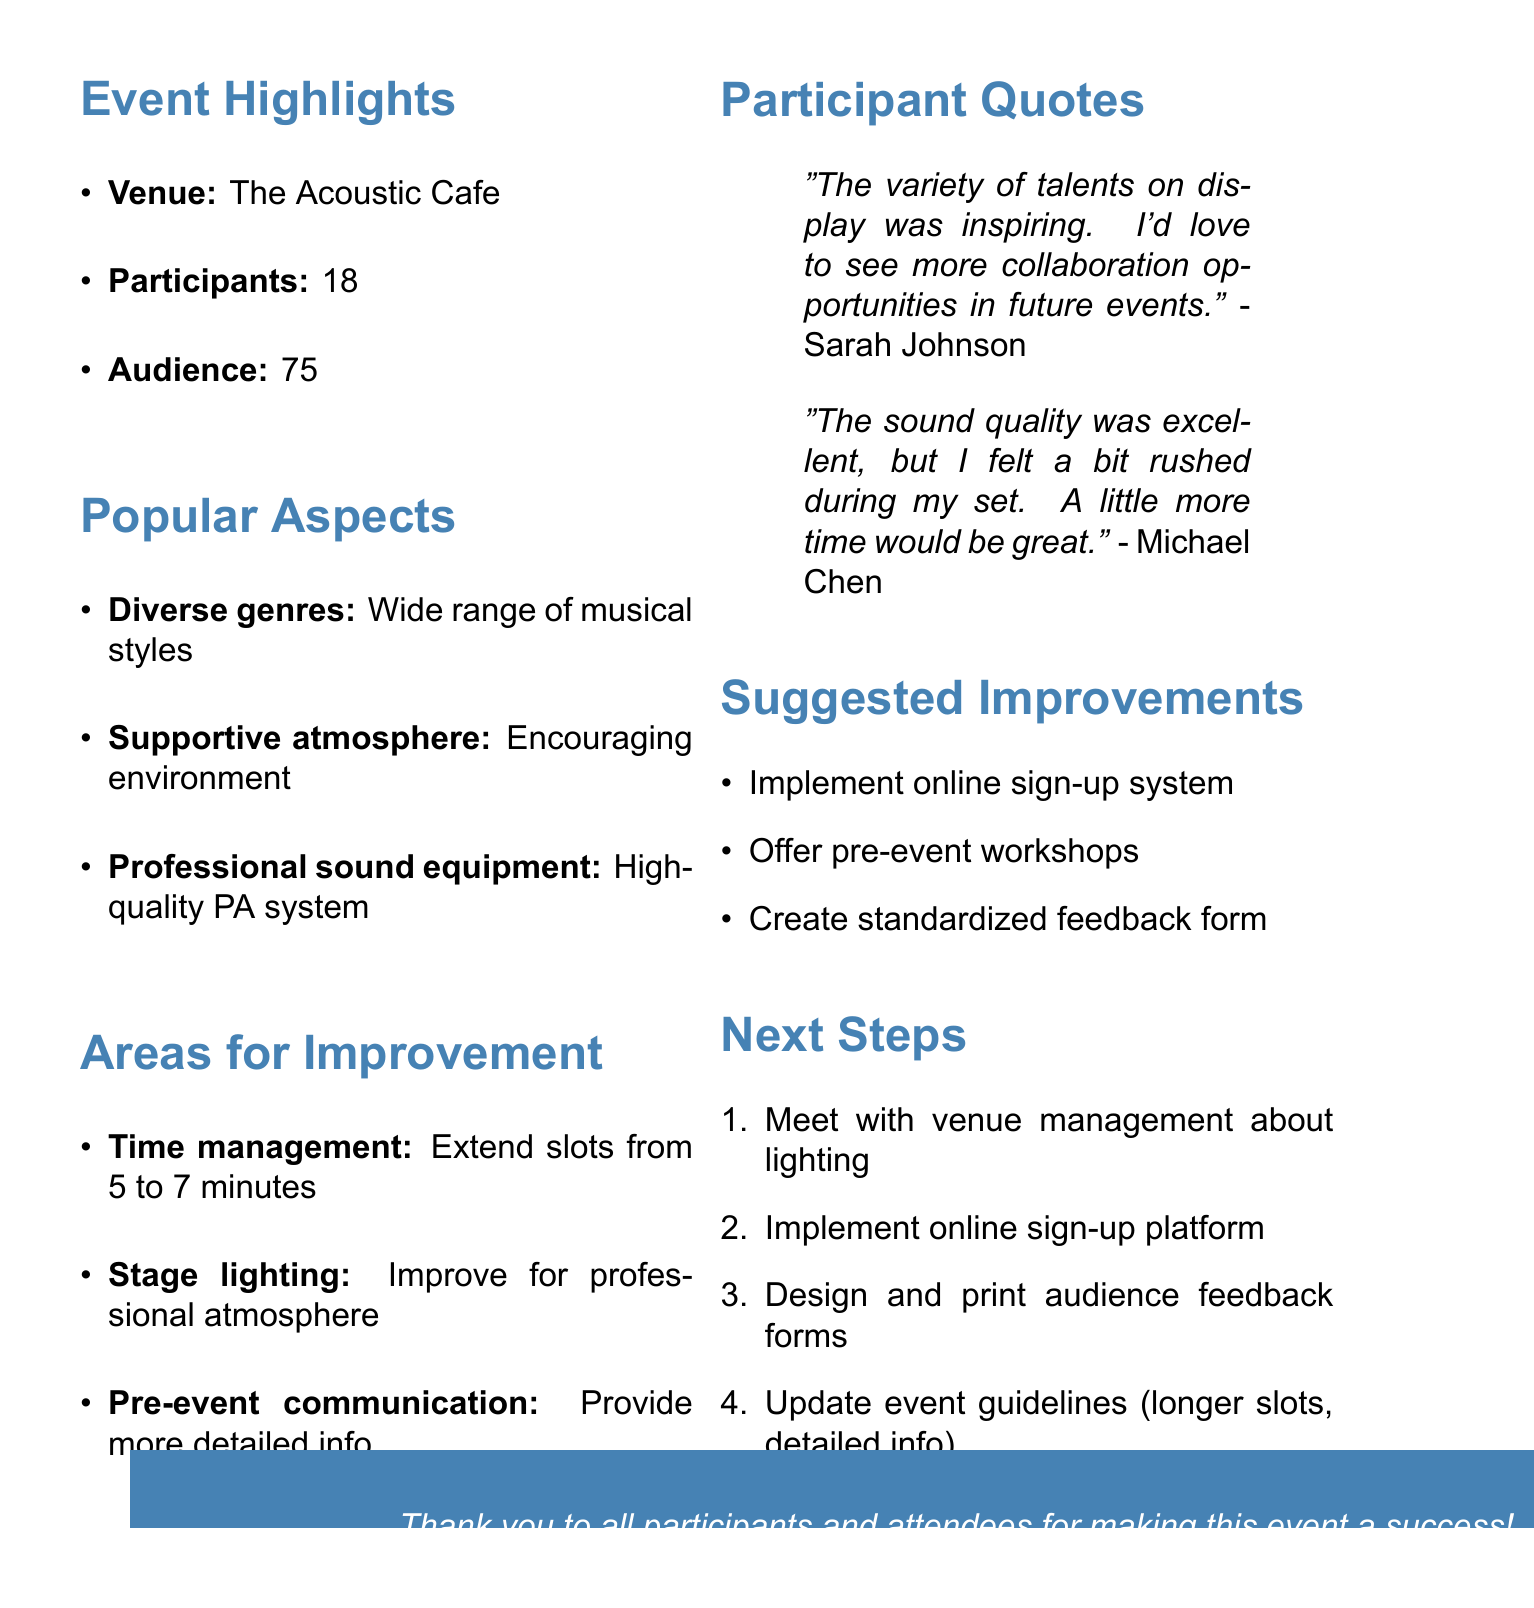What was the date of the event? The date of the event is explicitly mentioned in the document.
Answer: April 15, 2023 How many participants were there? The number of participants is stated in the event details section of the document.
Answer: 18 What is one popular aspect highlighted by participants? The document lists popular aspects that participants appreciated.
Answer: Diverse genres What area for improvement relates to performance time? One of the areas for improvement discusses the length of performance slots.
Answer: Time management Who suggested a desire for more collaboration opportunities? A participant quote mentions a desire for collaboration.
Answer: Sarah Johnson How many audience members attended the event? The number of audience members is mentioned in the event details.
Answer: 75 What is one suggested improvement for future events? The document specifies suggestions for enhancing future events.
Answer: Implement a sign-up system What is one next step mentioned regarding lighting? The next steps include actions to take to address feedback.
Answer: Schedule a meeting with The Acoustic Cafe management to discuss lighting improvements 